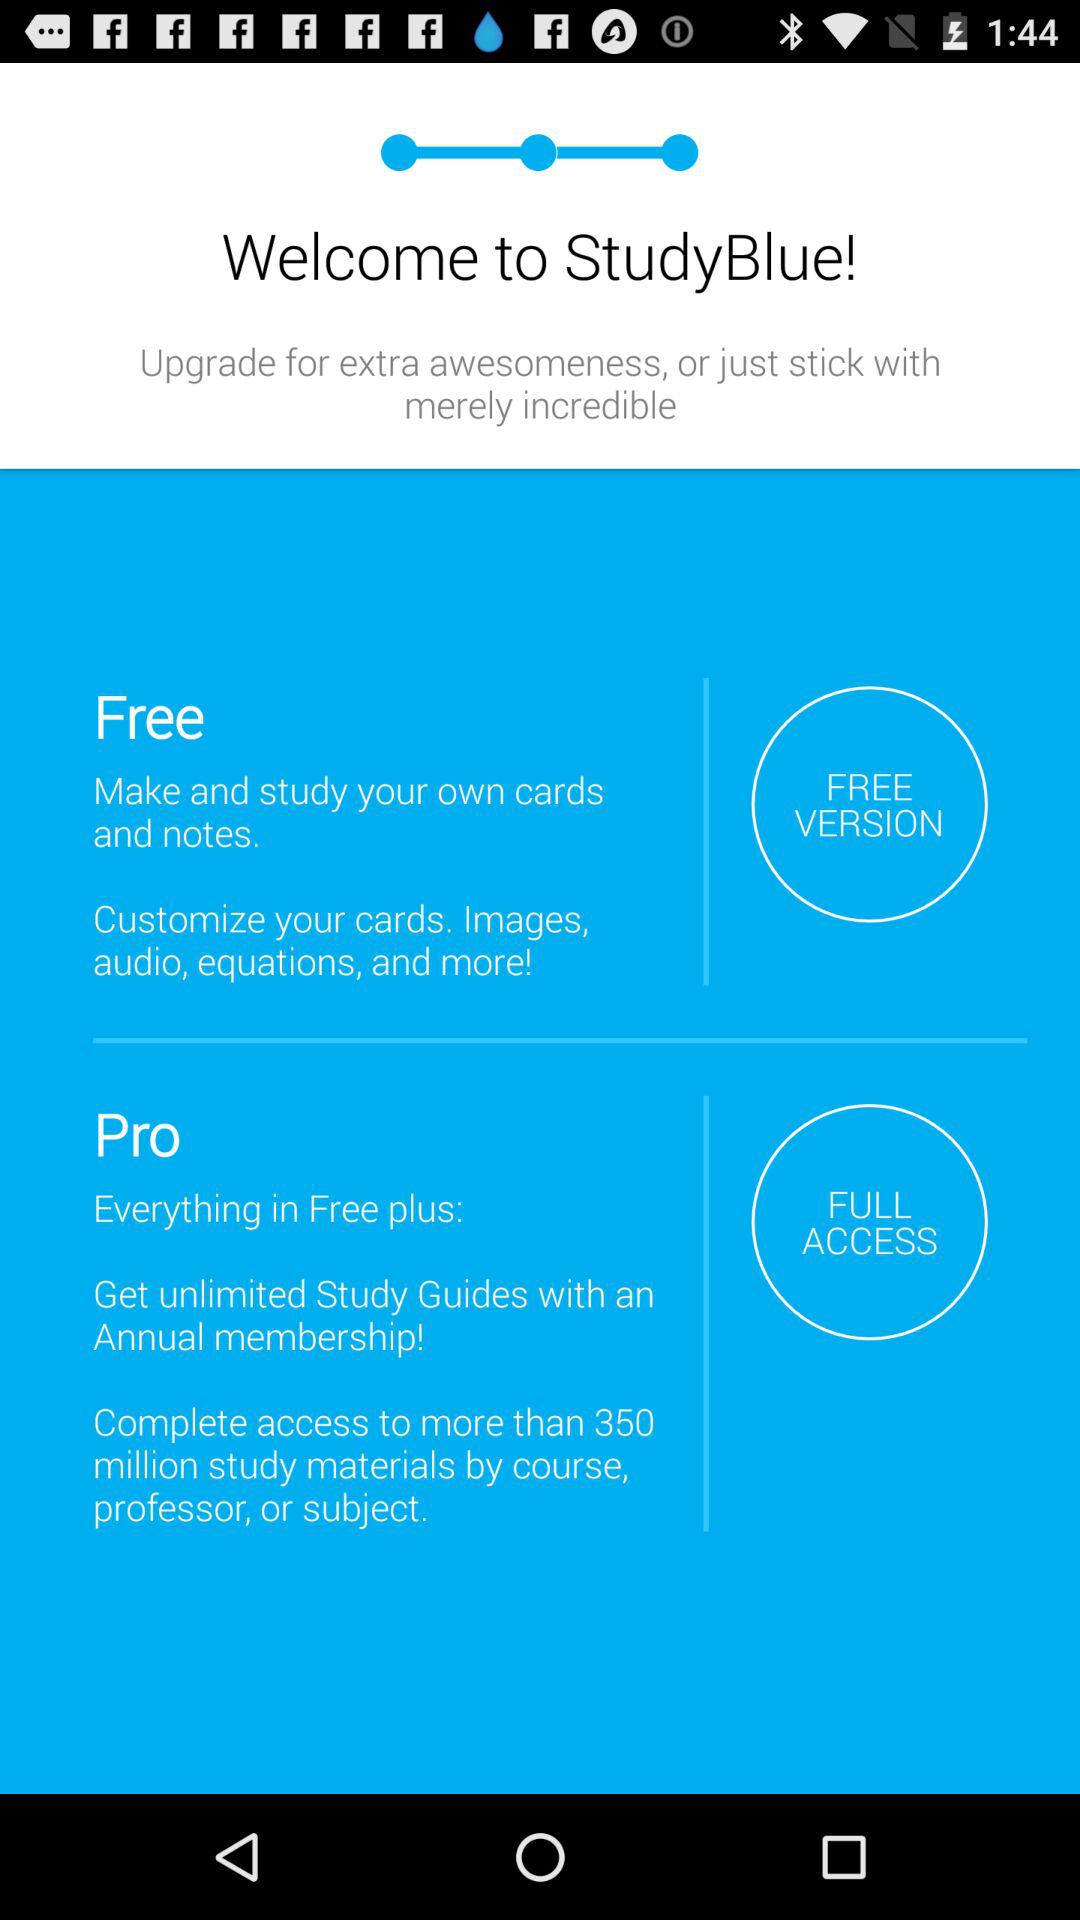What is the application name? The application name is "StudyBlue". 